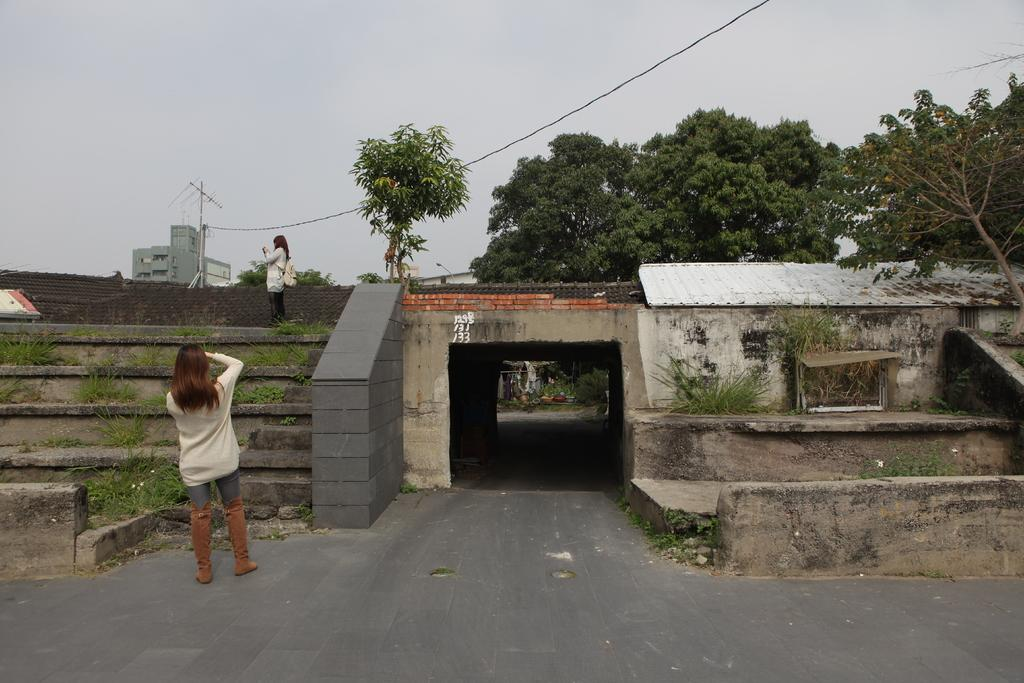What type of structure can be seen in the image? There is a bridge in the image. What type of vegetation is present in the image? There are trees, plants, and grass in the image. Are there any people in the image? Yes, there are people in the image. What other man-made structures can be seen in the image? There is an electric pole, a railing, stairs, and a building in the image. What can be seen in the background of the image? The sky is visible in the background of the image. Can you tell me how many chess pieces are on the bridge in the image? There are no chess pieces present in the image. What type of arithmetic problem is being solved by the people in the image? There is no indication of any arithmetic problem being solved in the image. 